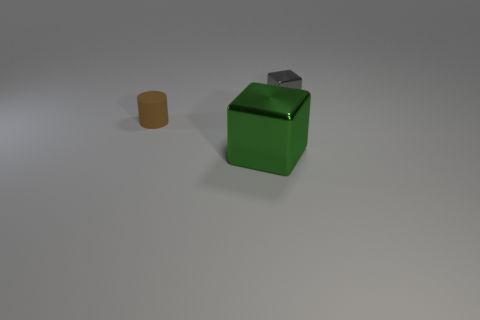Add 2 tiny red matte cylinders. How many objects exist? 5 Subtract all blocks. How many objects are left? 1 Subtract 1 cubes. How many cubes are left? 1 Add 3 big green rubber cubes. How many big green rubber cubes exist? 3 Subtract all green blocks. How many blocks are left? 1 Subtract 0 purple cubes. How many objects are left? 3 Subtract all yellow cylinders. Subtract all brown blocks. How many cylinders are left? 1 Subtract all red balls. How many gray blocks are left? 1 Subtract all small gray blocks. Subtract all tiny purple metal cylinders. How many objects are left? 2 Add 1 small metallic things. How many small metallic things are left? 2 